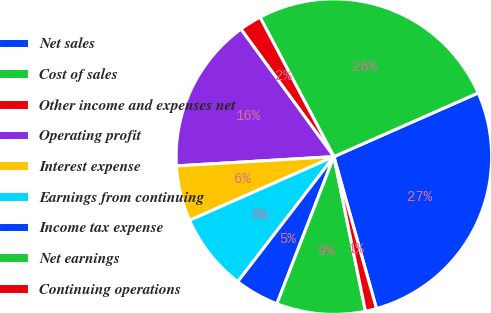Convert chart. <chart><loc_0><loc_0><loc_500><loc_500><pie_chart><fcel>Net sales<fcel>Cost of sales<fcel>Other income and expenses net<fcel>Operating profit<fcel>Interest expense<fcel>Earnings from continuing<fcel>Income tax expense<fcel>Net earnings<fcel>Continuing operations<nl><fcel>27.27%<fcel>26.14%<fcel>2.27%<fcel>15.91%<fcel>5.68%<fcel>7.95%<fcel>4.55%<fcel>9.09%<fcel>1.14%<nl></chart> 